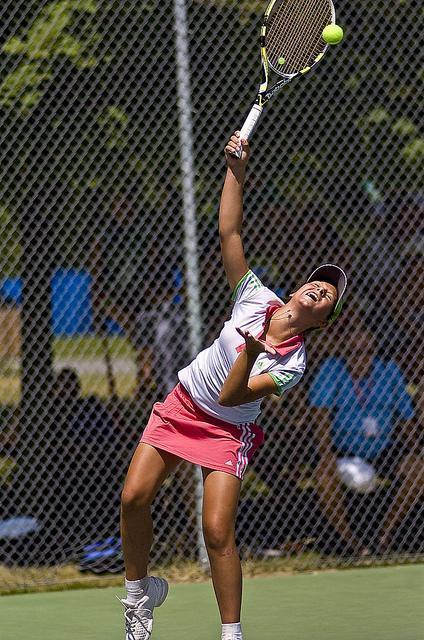How many people are in the picture?
Give a very brief answer. 3. How many of the chairs are blue?
Give a very brief answer. 0. 